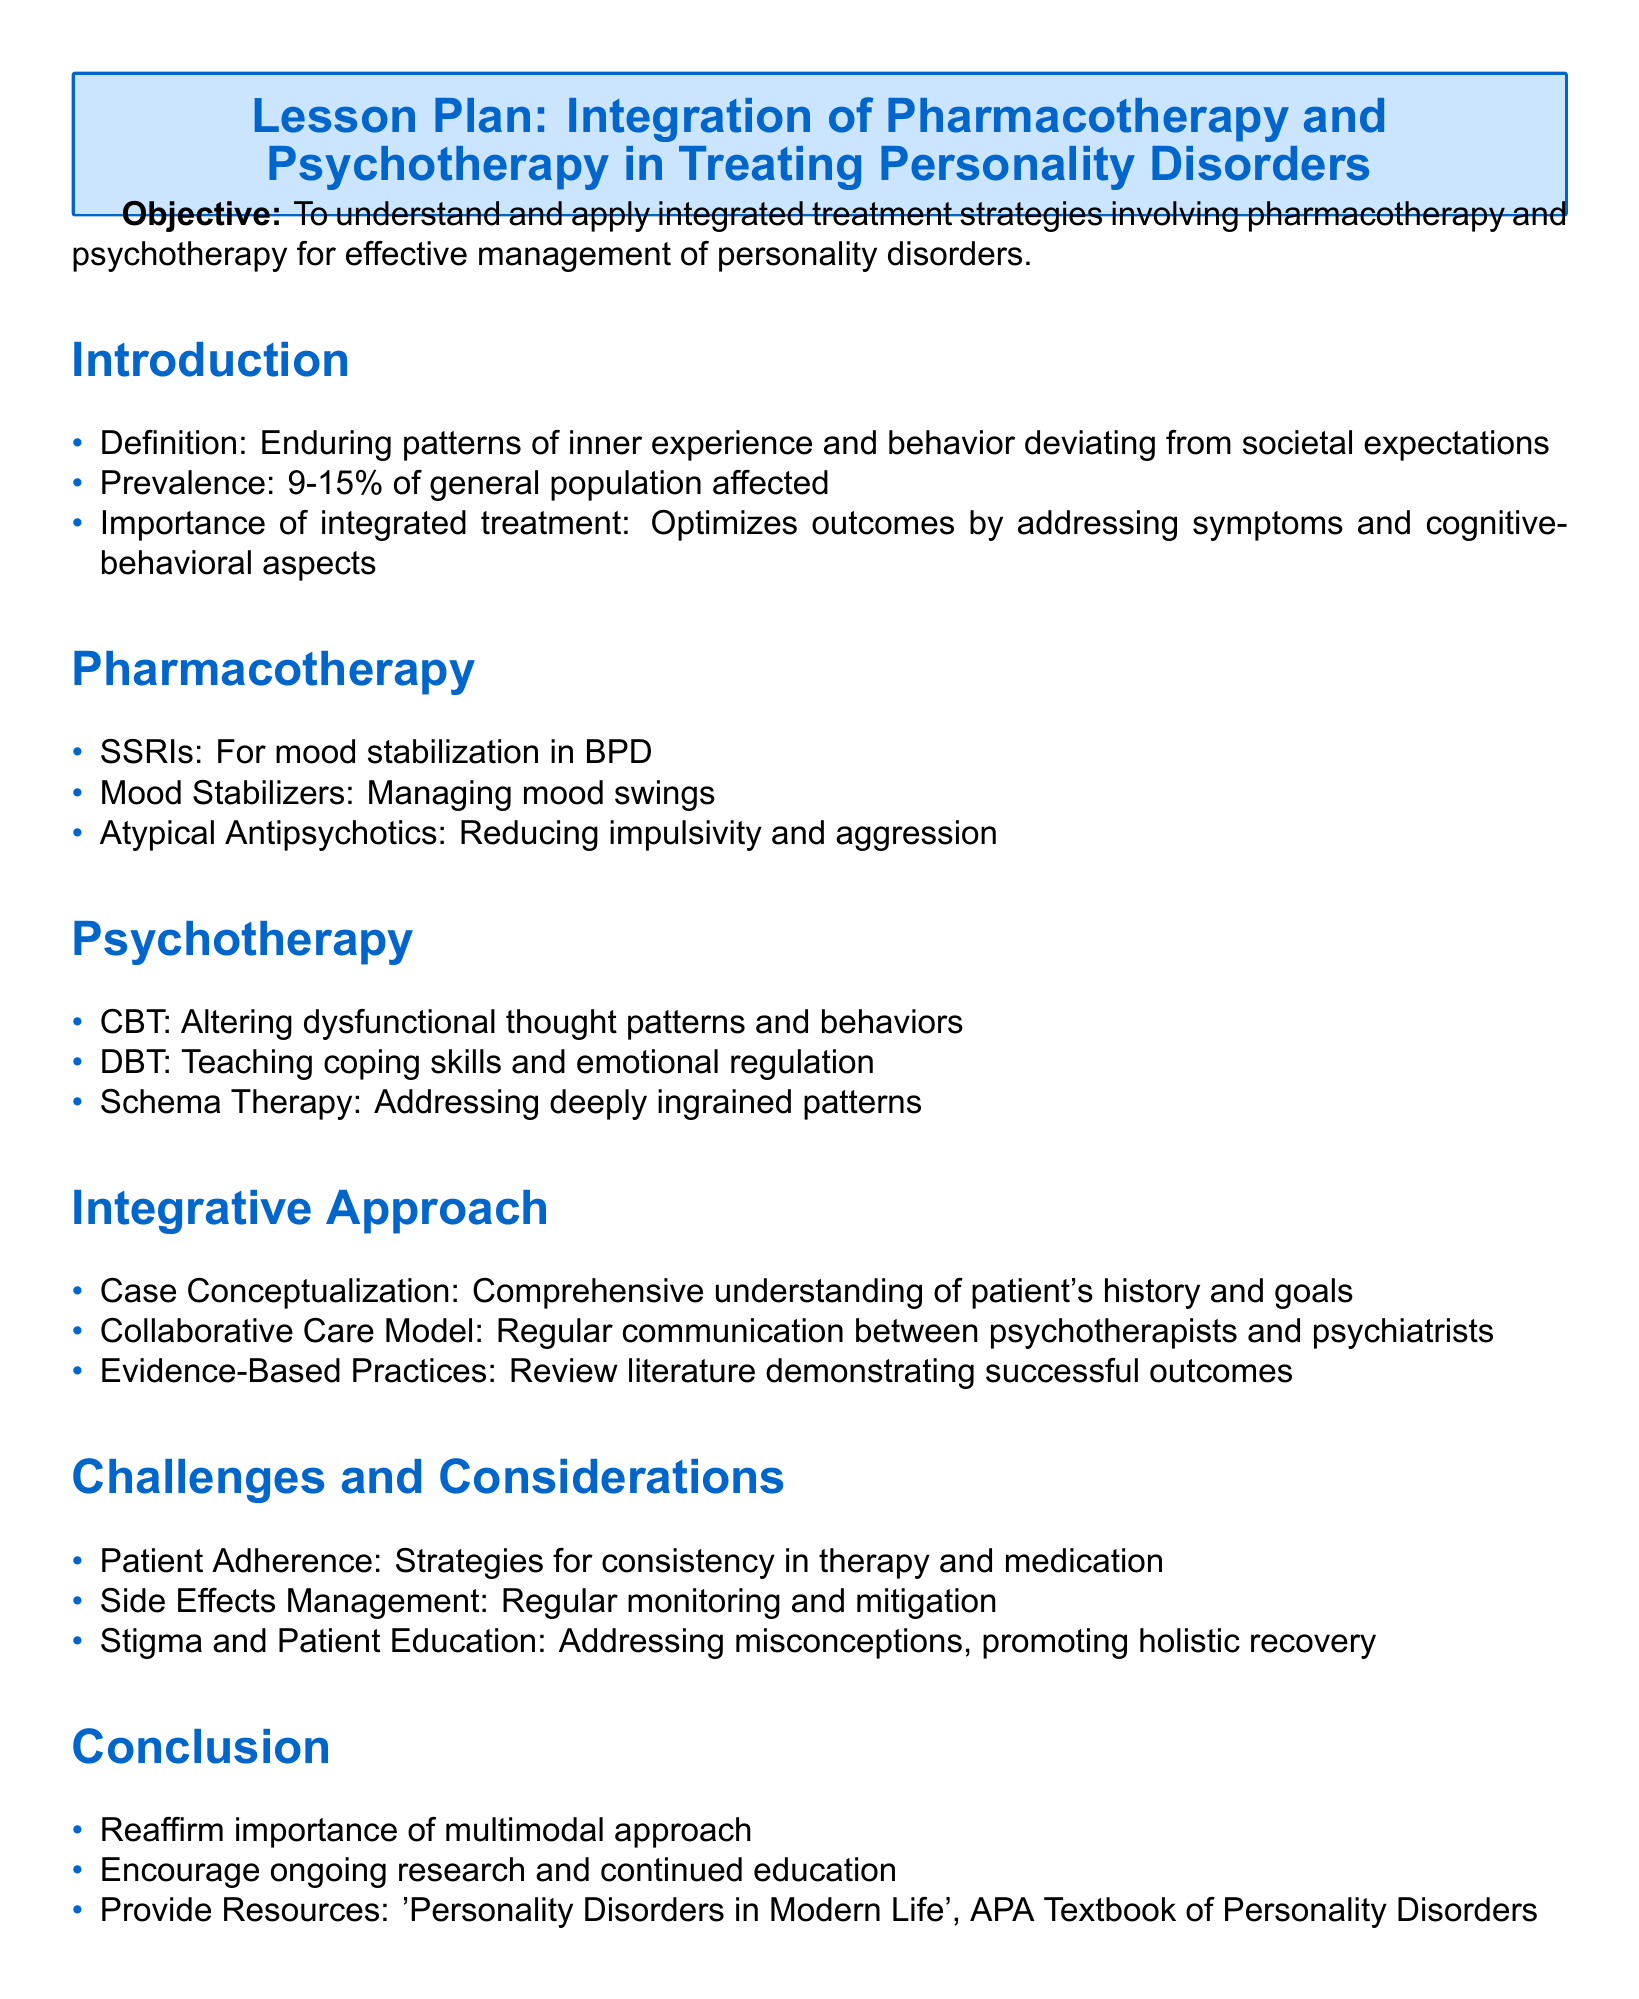What is the objective of the lesson plan? The objective is outlined as understanding and applying integrated treatment strategies involving pharmacotherapy and psychotherapy for effective management of personality disorders.
Answer: To understand and apply integrated treatment strategies What percentage of the general population is affected by personality disorders? The document states that 9-15% of the general population is affected by personality disorders.
Answer: 9-15% Which medication type is mentioned for mood stabilization in BPD? The document specifically lists SSRIs as being used for mood stabilization in borderline personality disorder (BPD).
Answer: SSRIs What therapy teaches coping skills and emotional regulation? The document identifies DBT as the therapy that teaches coping skills and emotional regulation.
Answer: DBT What is an important part of the integrative approach according to the document? The integrative approach emphasizes case conceptualization as a key component for understanding the patient's history and goals.
Answer: Case Conceptualization What is a challenge related to patient adherence? The document mentions the need for strategies to ensure consistency in therapy and medication as a challenge related to patient adherence.
Answer: Strategies for consistency What type of practices does the integrative approach focus on? The integrative approach emphasizes evidence-based practices, indicating a reliance on researched and validated methods for treatment.
Answer: Evidence-Based Practices What resource is suggested in the conclusion of the lesson plan? The document recommends the "APA Textbook of Personality Disorders" as a resource in the conclusion section.
Answer: APA Textbook of Personality Disorders 